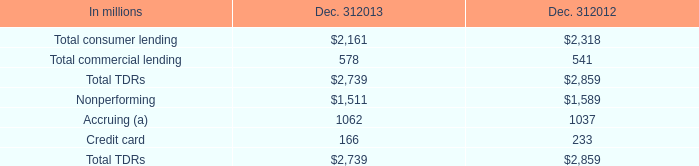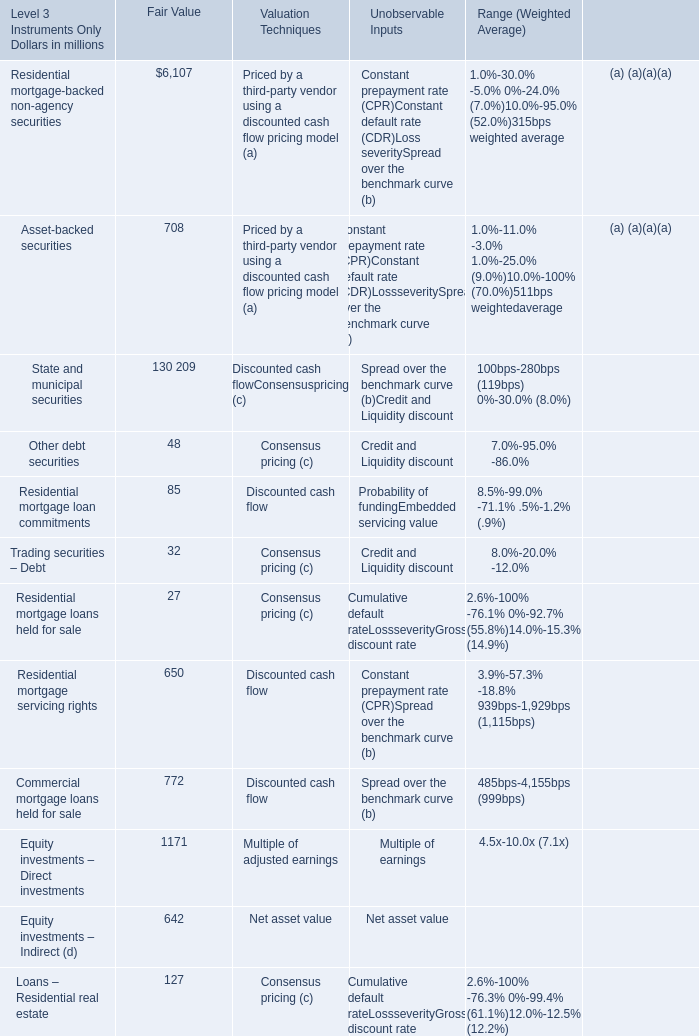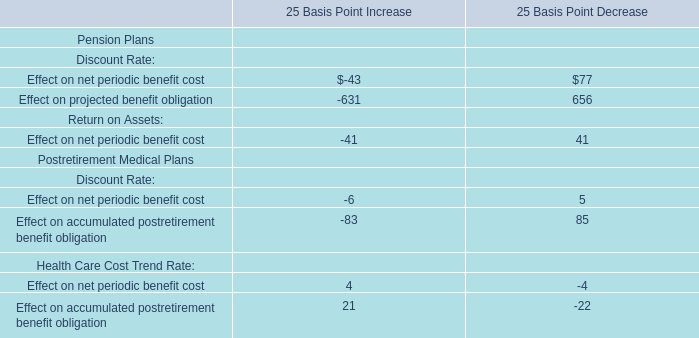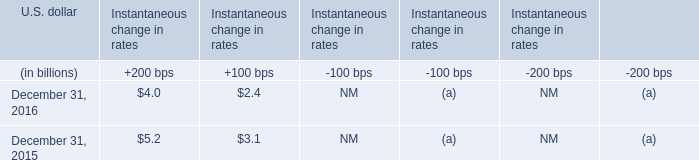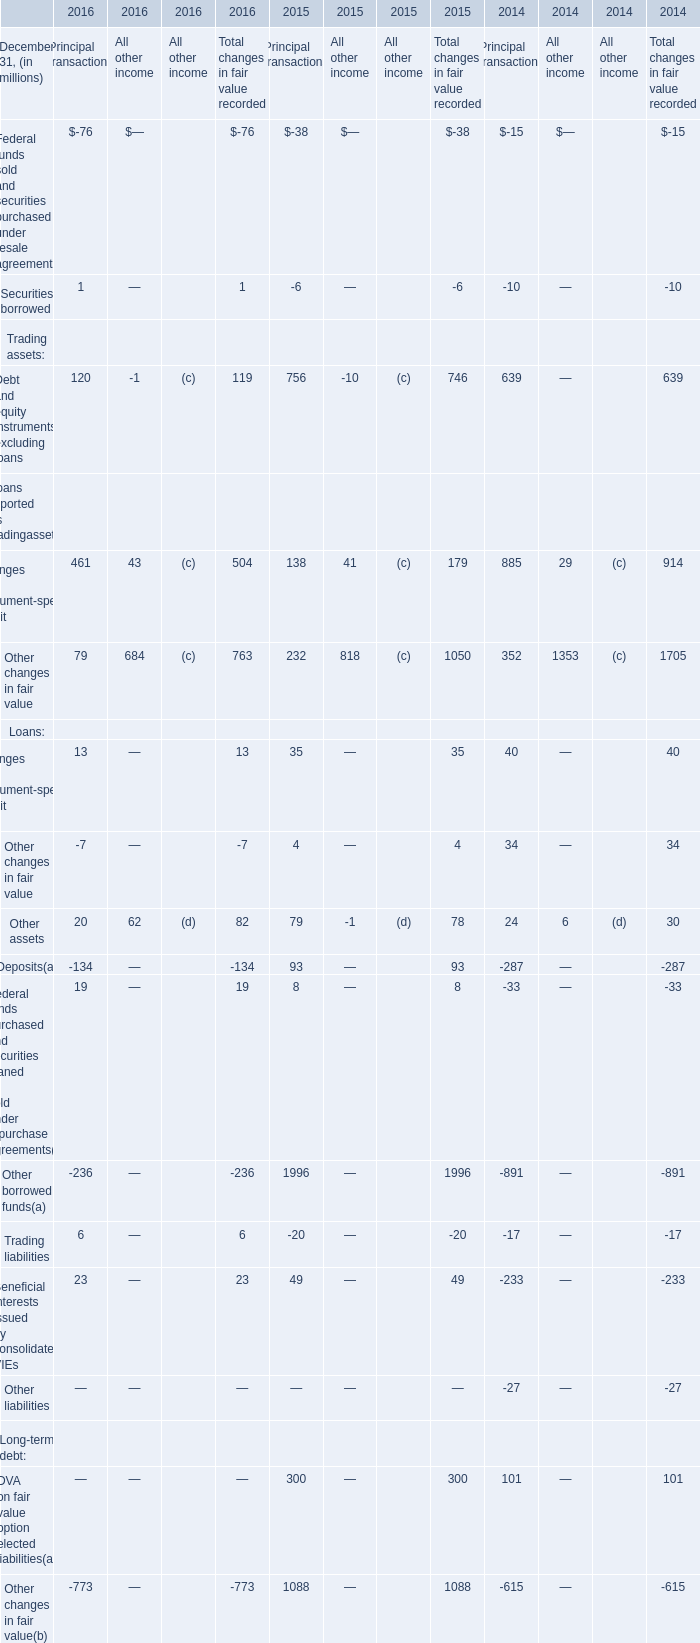As As the chart 1 shows,what is the Fair Value for Commercial mortgage loans held for sale for Level 3 Instruments Only? (in million) 
Answer: 772. 